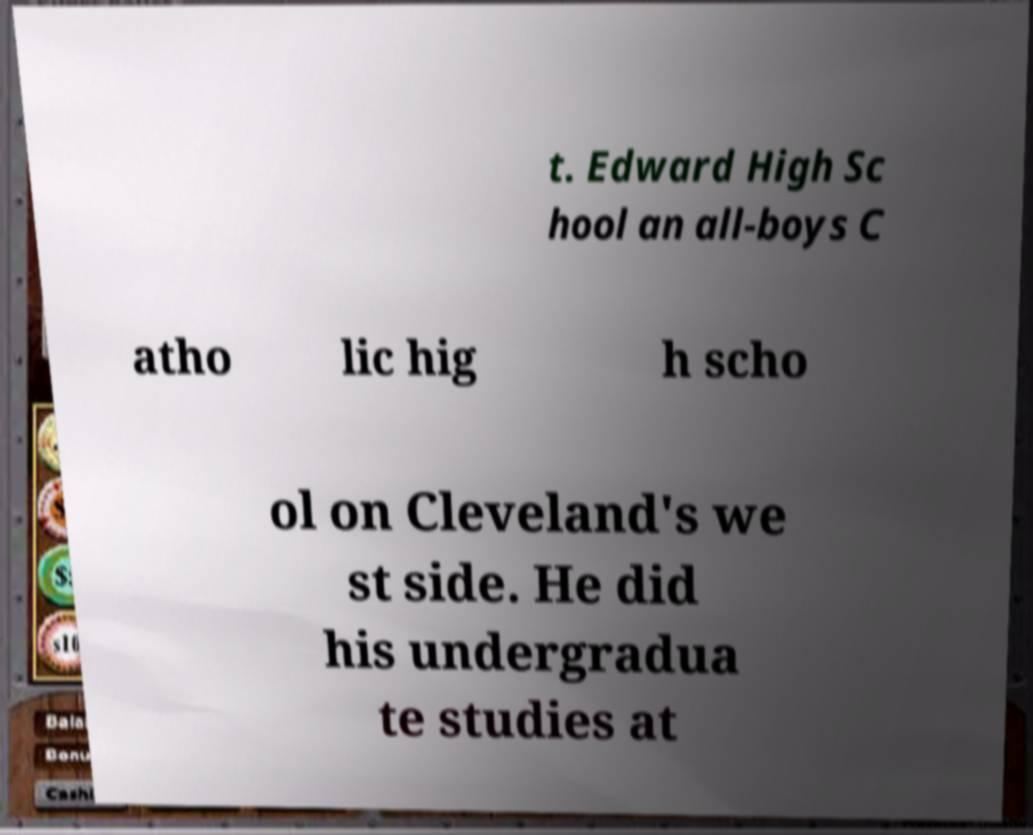I need the written content from this picture converted into text. Can you do that? t. Edward High Sc hool an all-boys C atho lic hig h scho ol on Cleveland's we st side. He did his undergradua te studies at 